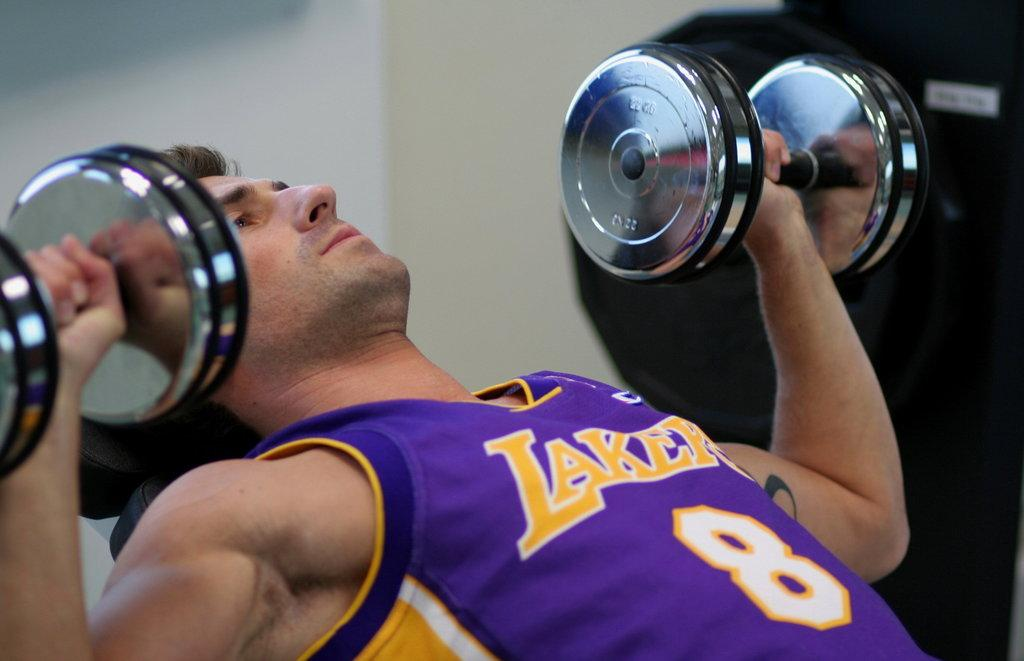<image>
Present a compact description of the photo's key features. a man lifting weights while wearing a lakers jersey 